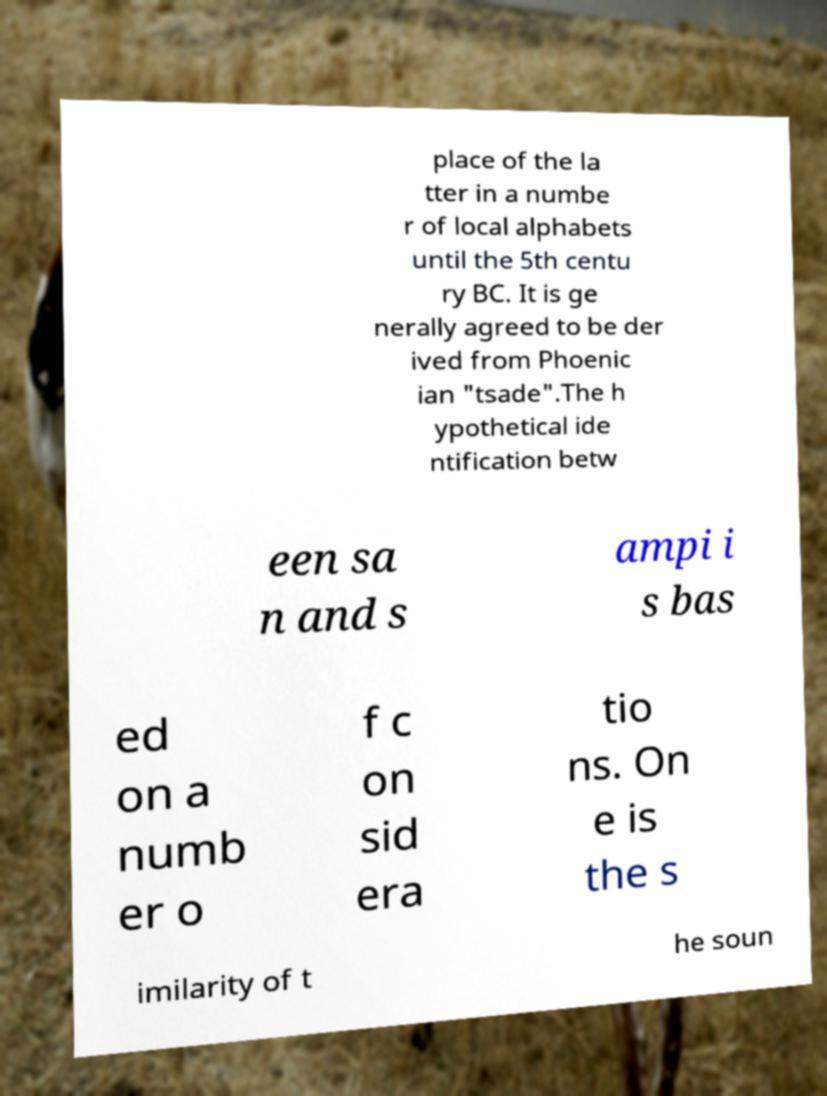Can you accurately transcribe the text from the provided image for me? place of the la tter in a numbe r of local alphabets until the 5th centu ry BC. It is ge nerally agreed to be der ived from Phoenic ian "tsade".The h ypothetical ide ntification betw een sa n and s ampi i s bas ed on a numb er o f c on sid era tio ns. On e is the s imilarity of t he soun 